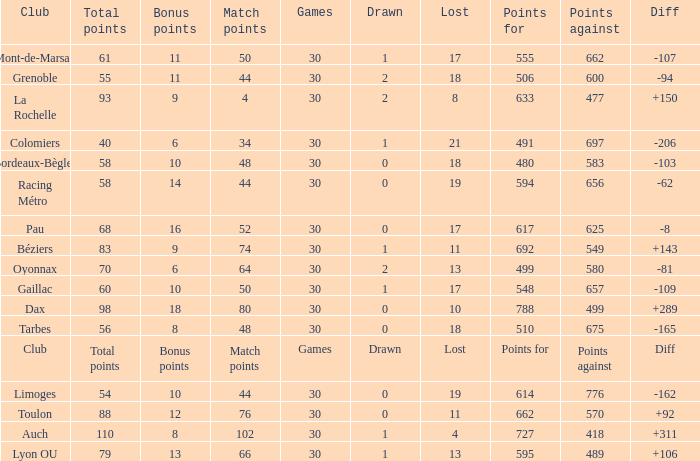What is the value of match points when the points for is 570? 76.0. 